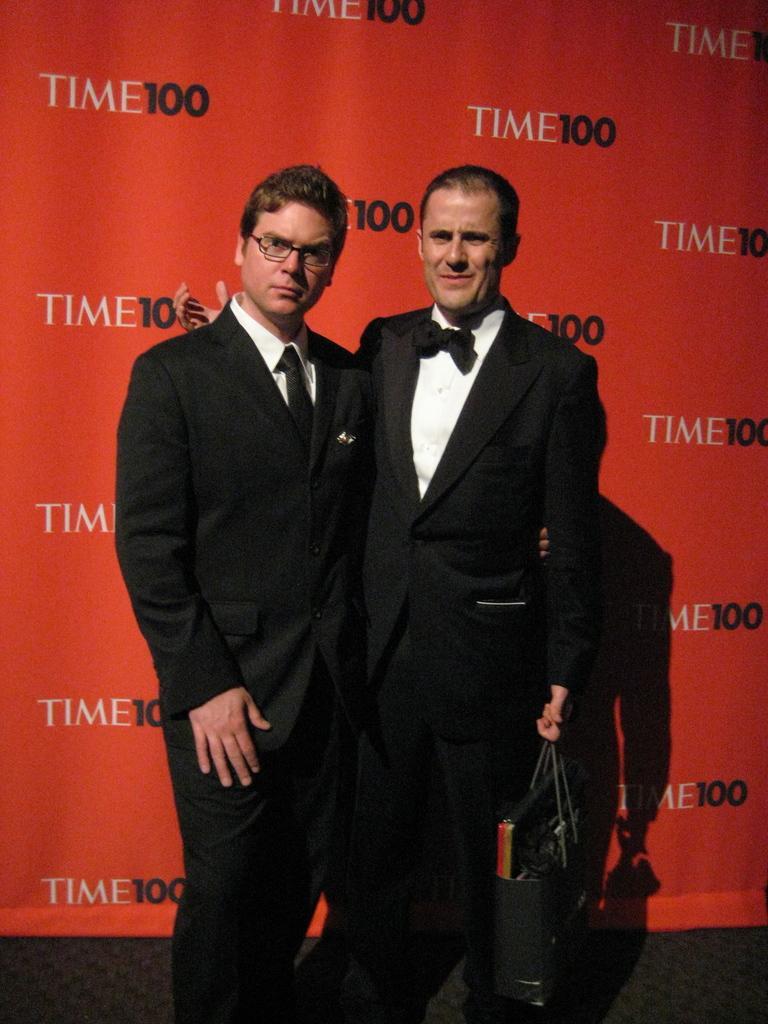Could you give a brief overview of what you see in this image? In this image there are two men standing, there is a man wearing spectacles, there is a man holding an object, at the background of the image there is a red colored cloth, there is text on the cloth, there is a number on the cloth. 